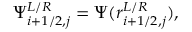Convert formula to latex. <formula><loc_0><loc_0><loc_500><loc_500>\Psi _ { i + 1 / 2 , j } ^ { L / R } = \Psi ( r _ { i + 1 / 2 , j } ^ { L / R } ) ,</formula> 